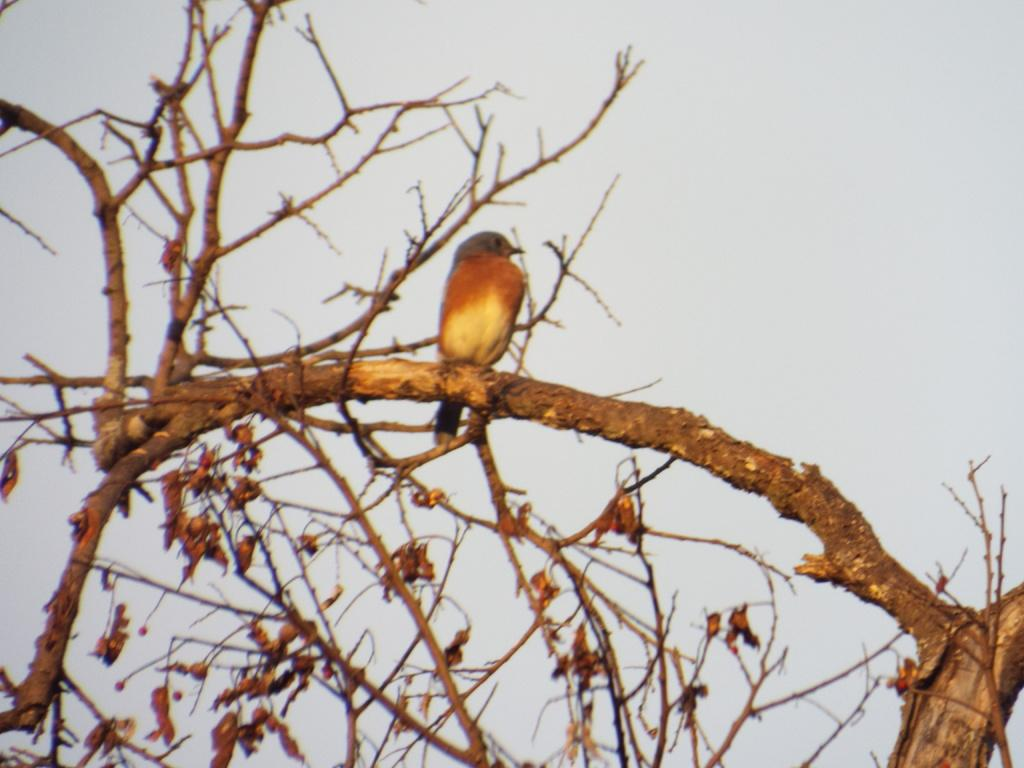What is the condition of the tree in the image? The tree in the image is dry. Is there any wildlife present in the image? Yes, there is a bird on the tree in the image. What can be seen in the background of the image? The sky is visible in the background of the image. What type of tray is being used to hold the volcano in the image? There is no tray or volcano present in the image; it features a dry tree with a bird on it. What time of day is it in the image, considering the afternoon? The time of day cannot be determined from the image, as there are no specific clues or indicators of the time. 